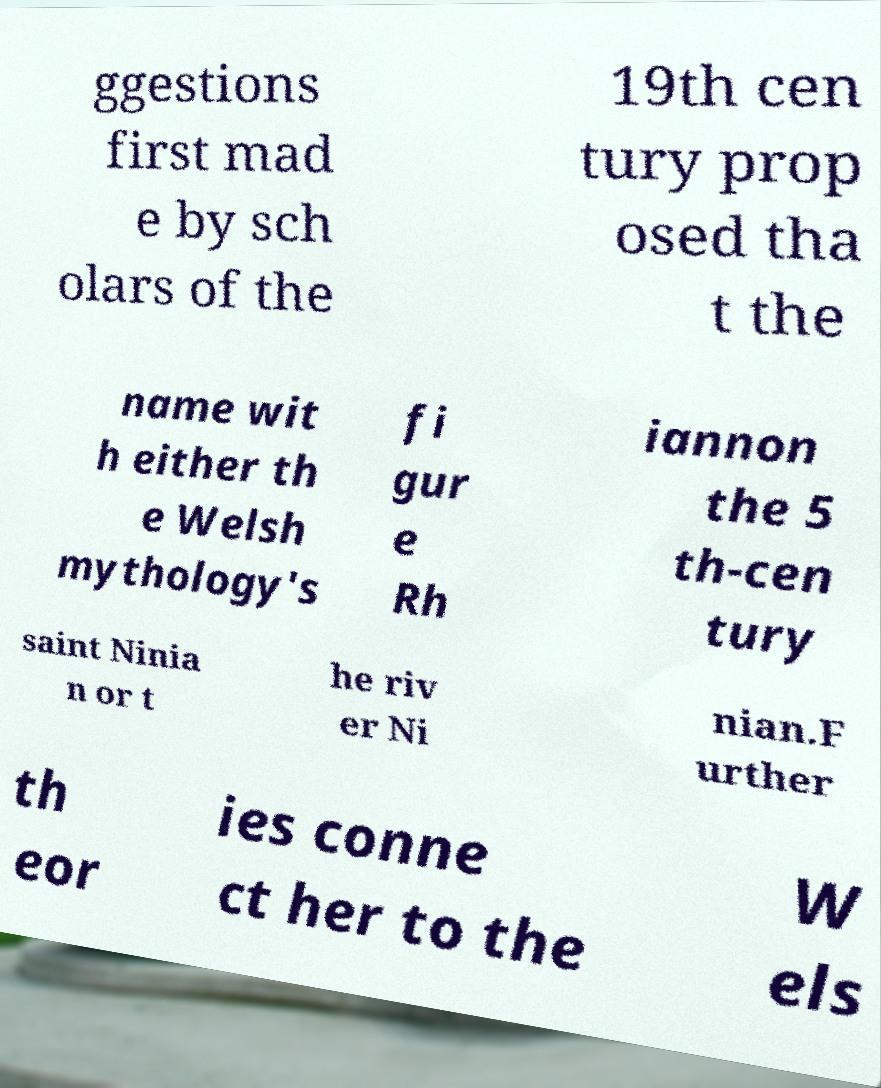I need the written content from this picture converted into text. Can you do that? ggestions first mad e by sch olars of the 19th cen tury prop osed tha t the name wit h either th e Welsh mythology's fi gur e Rh iannon the 5 th-cen tury saint Ninia n or t he riv er Ni nian.F urther th eor ies conne ct her to the W els 